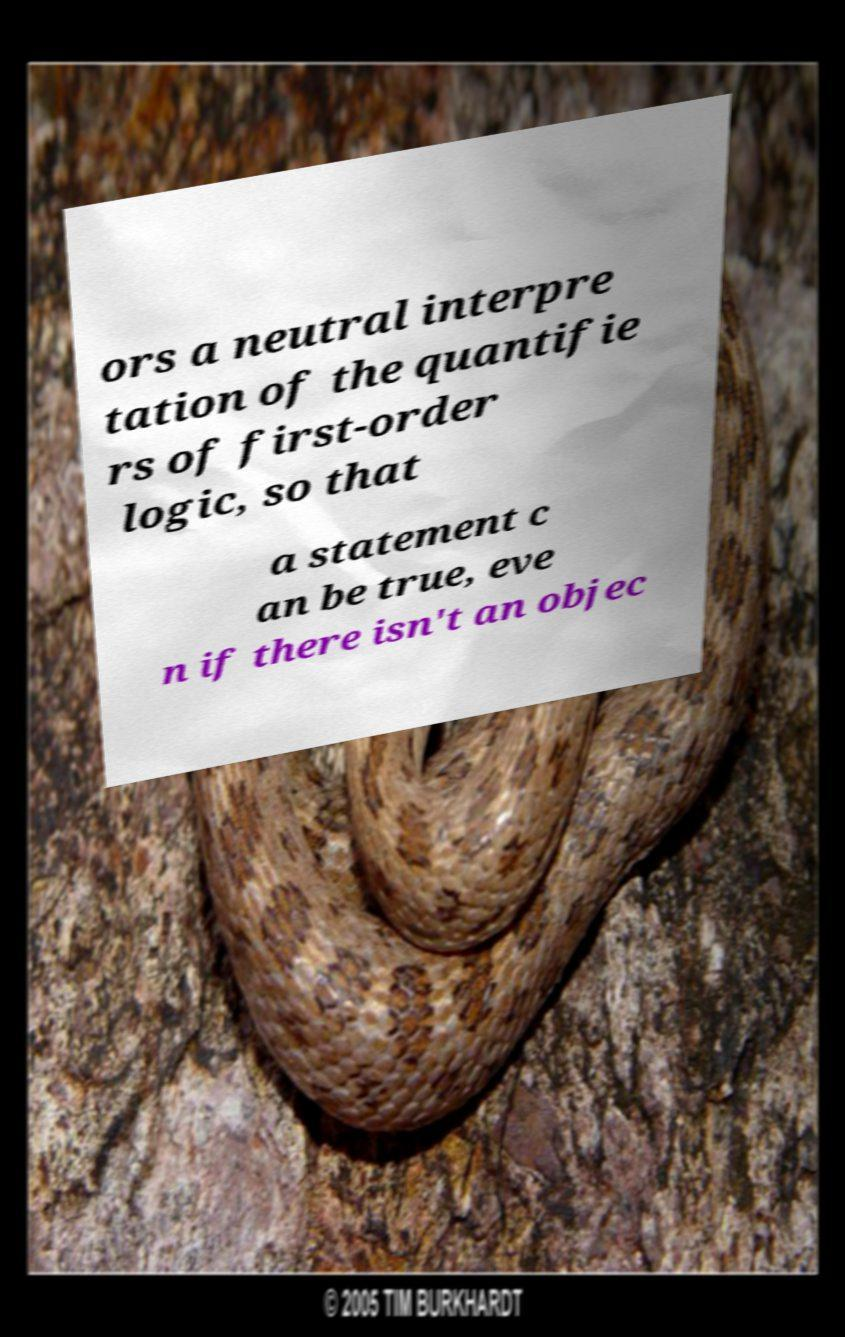I need the written content from this picture converted into text. Can you do that? ors a neutral interpre tation of the quantifie rs of first-order logic, so that a statement c an be true, eve n if there isn't an objec 